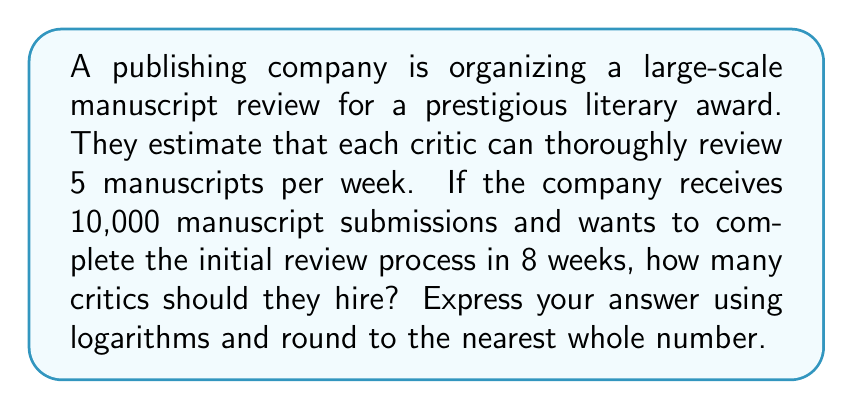Teach me how to tackle this problem. Let's approach this step-by-step:

1) First, let's define our variables:
   $x$ = number of critics needed
   $m$ = number of manuscripts (10,000)
   $w$ = number of weeks (8)
   $r$ = review rate per critic per week (5)

2) We can set up the equation:
   $x \cdot r \cdot w = m$

3) Substituting our known values:
   $x \cdot 5 \cdot 8 = 10,000$

4) Simplify:
   $40x = 10,000$

5) To solve for $x$, we divide both sides by 40:
   $x = \frac{10,000}{40} = 250$

6) Now, to express this using logarithms, we can rewrite our original equation:
   $\log(x \cdot r \cdot w) = \log(m)$

7) Using the properties of logarithms, we can separate this:
   $\log(x) + \log(r) + \log(w) = \log(m)$

8) Solve for $\log(x)$:
   $\log(x) = \log(m) - \log(r) - \log(w)$

9) Now we can substitute our values:
   $\log(x) = \log(10,000) - \log(5) - \log(8)$

10) Using the properties of logarithms again:
    $\log(x) = \log(\frac{10,000}{5 \cdot 8}) = \log(250)$

11) Therefore:
    $x = 10^{\log(250)} = 250$

The answer is already a whole number, so no rounding is necessary.
Answer: $x = 250$ critics 